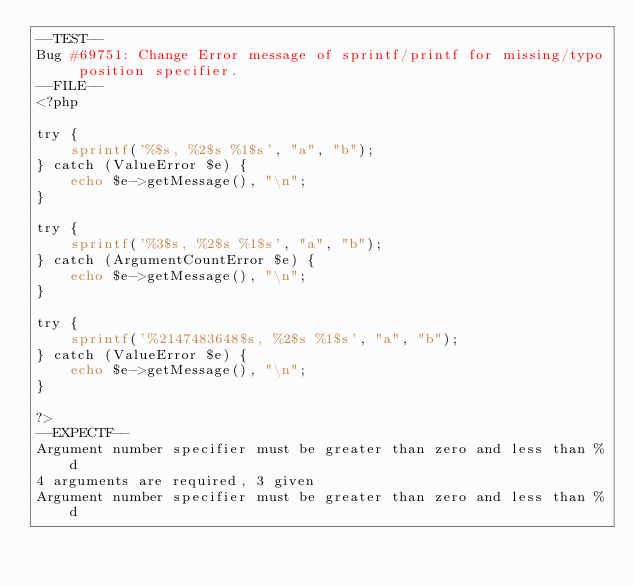Convert code to text. <code><loc_0><loc_0><loc_500><loc_500><_PHP_>--TEST--
Bug #69751: Change Error message of sprintf/printf for missing/typo position specifier.
--FILE--
<?php

try {
    sprintf('%$s, %2$s %1$s', "a", "b");
} catch (ValueError $e) {
    echo $e->getMessage(), "\n";
}

try {
    sprintf('%3$s, %2$s %1$s', "a", "b");
} catch (ArgumentCountError $e) {
    echo $e->getMessage(), "\n";
}

try {
    sprintf('%2147483648$s, %2$s %1$s', "a", "b");
} catch (ValueError $e) {
    echo $e->getMessage(), "\n";
}

?>
--EXPECTF--
Argument number specifier must be greater than zero and less than %d
4 arguments are required, 3 given
Argument number specifier must be greater than zero and less than %d
</code> 